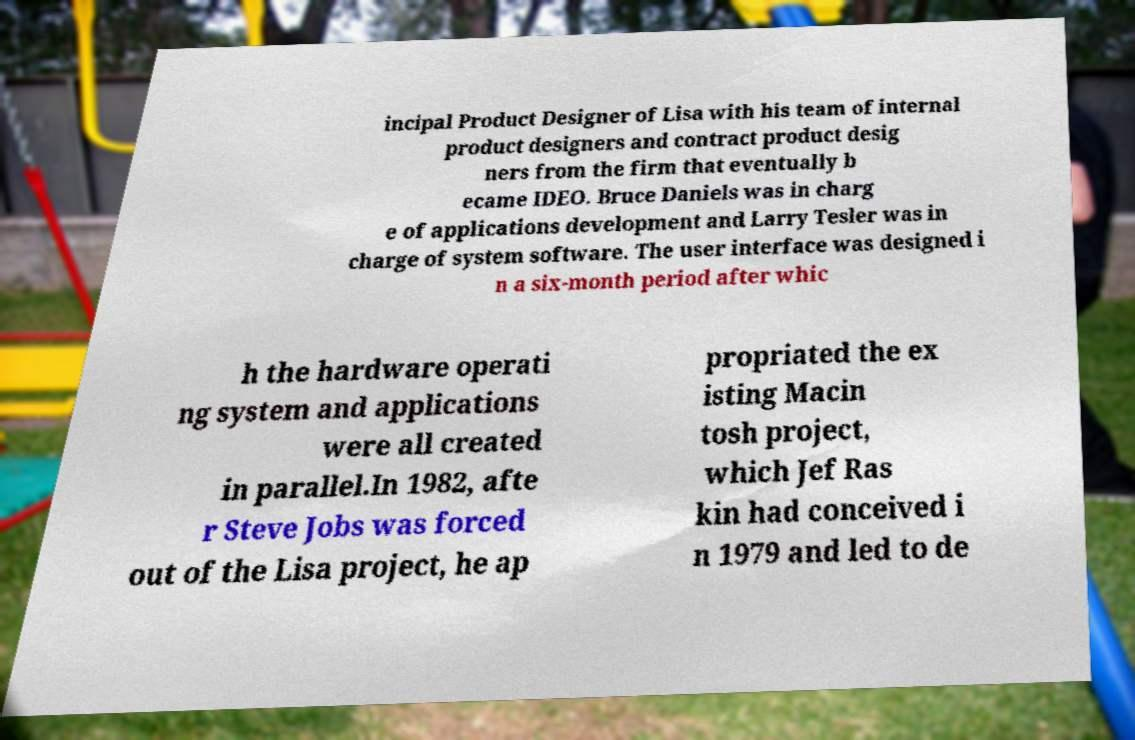Please read and relay the text visible in this image. What does it say? incipal Product Designer of Lisa with his team of internal product designers and contract product desig ners from the firm that eventually b ecame IDEO. Bruce Daniels was in charg e of applications development and Larry Tesler was in charge of system software. The user interface was designed i n a six-month period after whic h the hardware operati ng system and applications were all created in parallel.In 1982, afte r Steve Jobs was forced out of the Lisa project, he ap propriated the ex isting Macin tosh project, which Jef Ras kin had conceived i n 1979 and led to de 